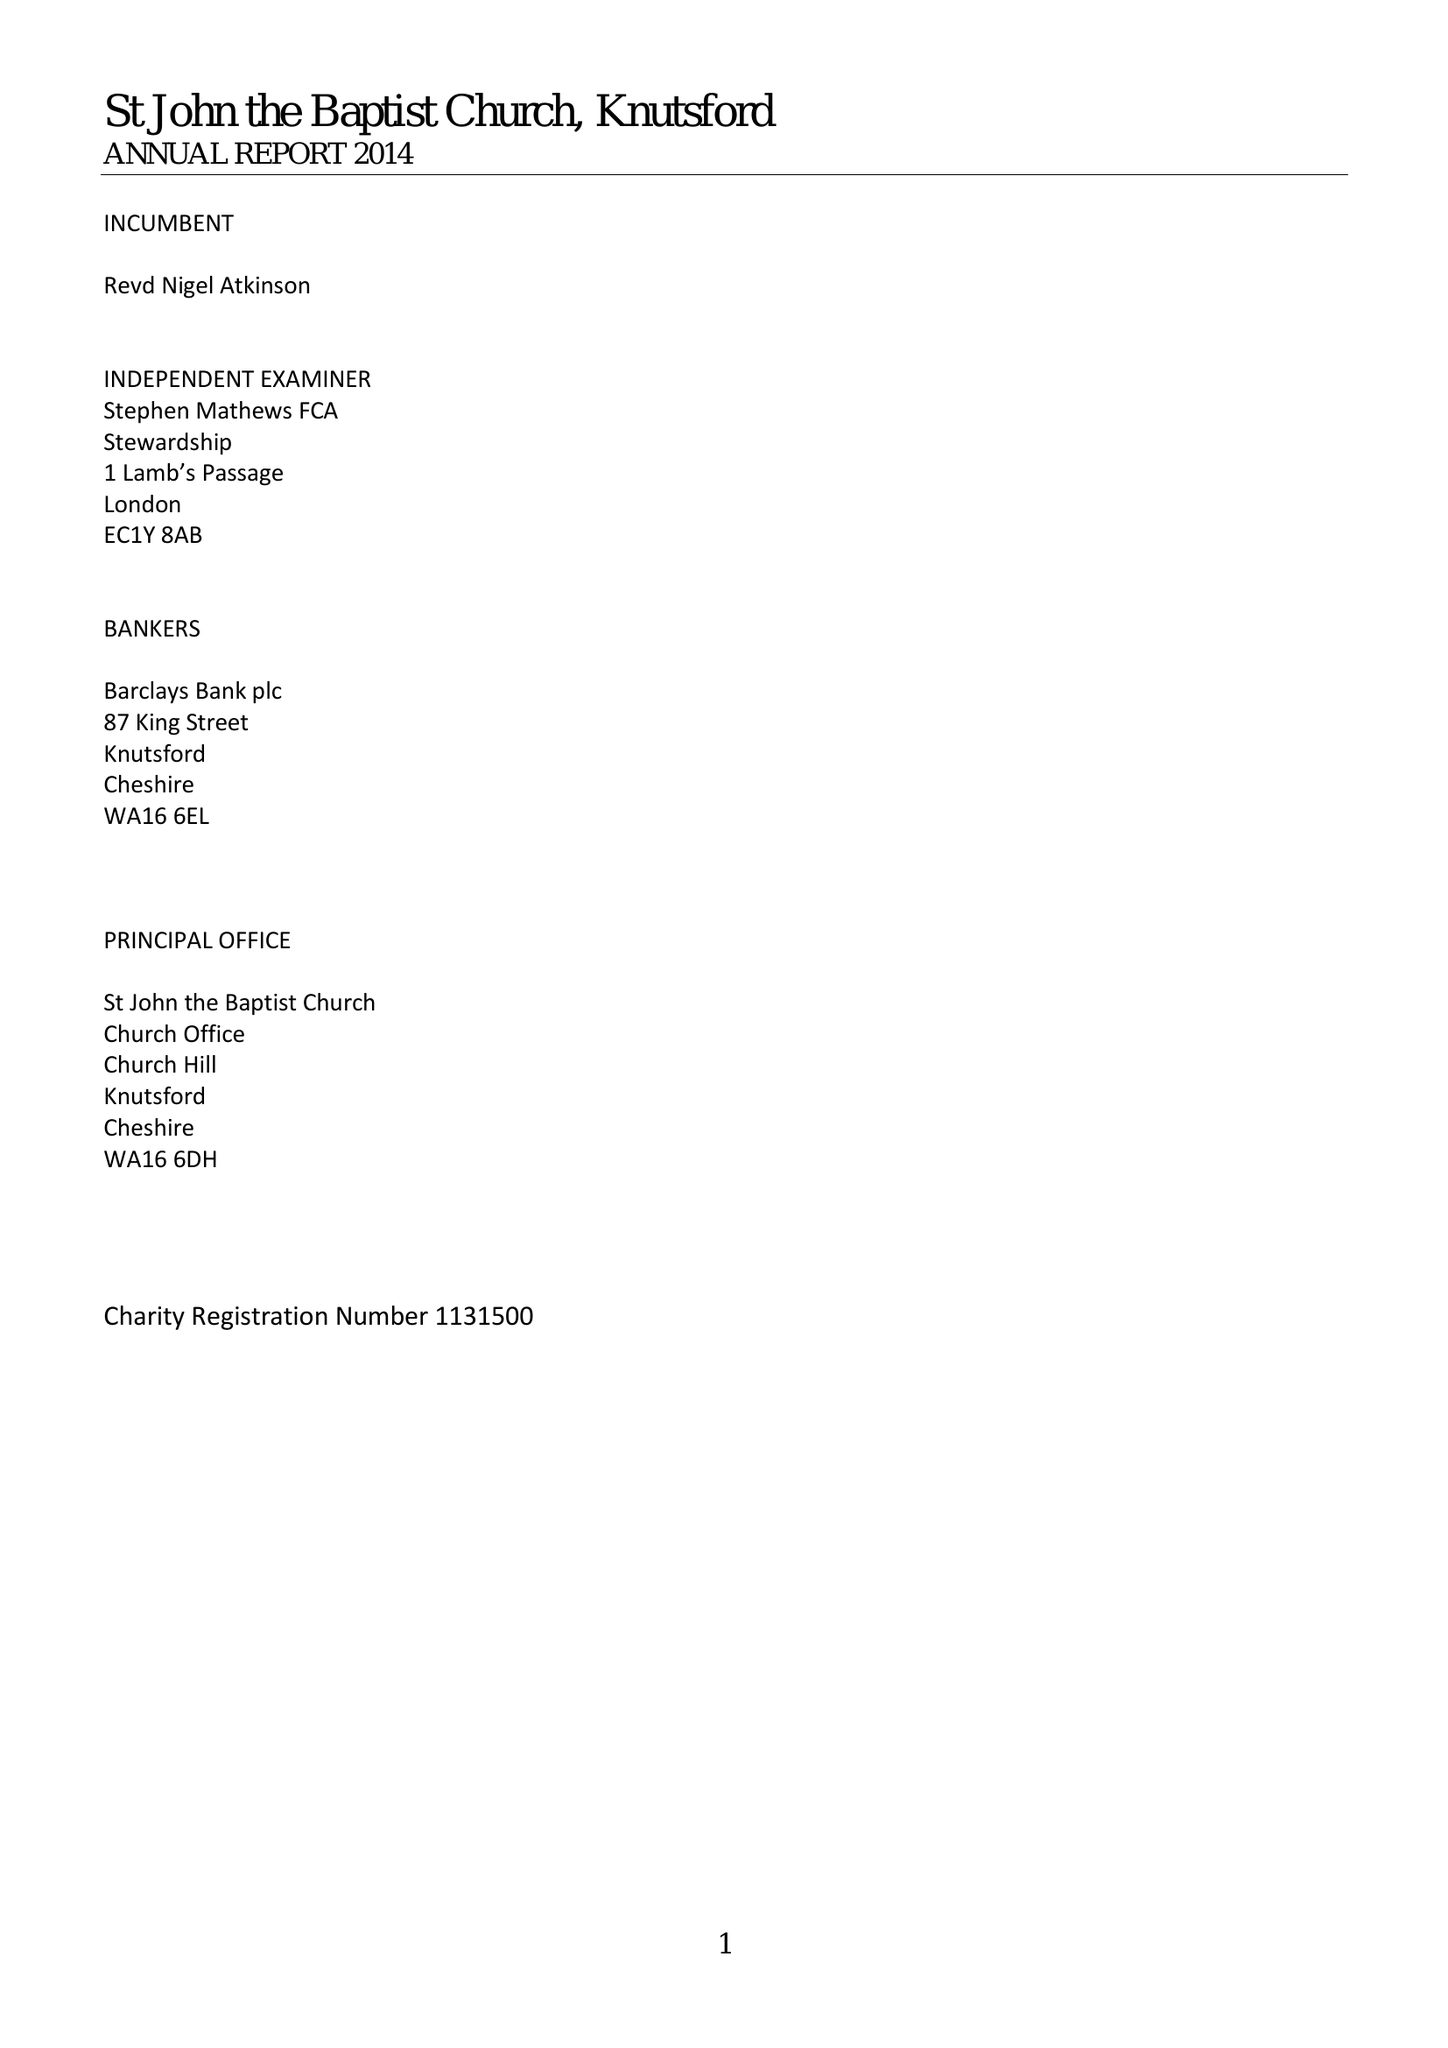What is the value for the income_annually_in_british_pounds?
Answer the question using a single word or phrase. 566788.00 